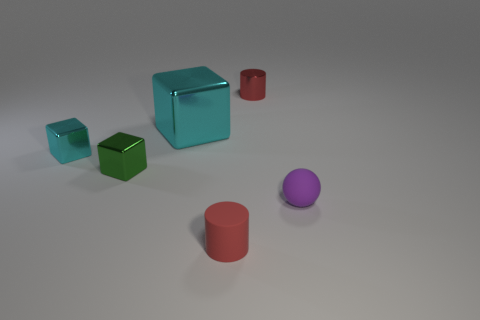Subtract all yellow cylinders. Subtract all yellow balls. How many cylinders are left? 2 Add 3 big cyan shiny objects. How many objects exist? 9 Subtract all cylinders. How many objects are left? 4 Add 5 large purple cylinders. How many large purple cylinders exist? 5 Subtract 0 blue cylinders. How many objects are left? 6 Subtract all green shiny blocks. Subtract all tiny metallic blocks. How many objects are left? 3 Add 4 large cyan objects. How many large cyan objects are left? 5 